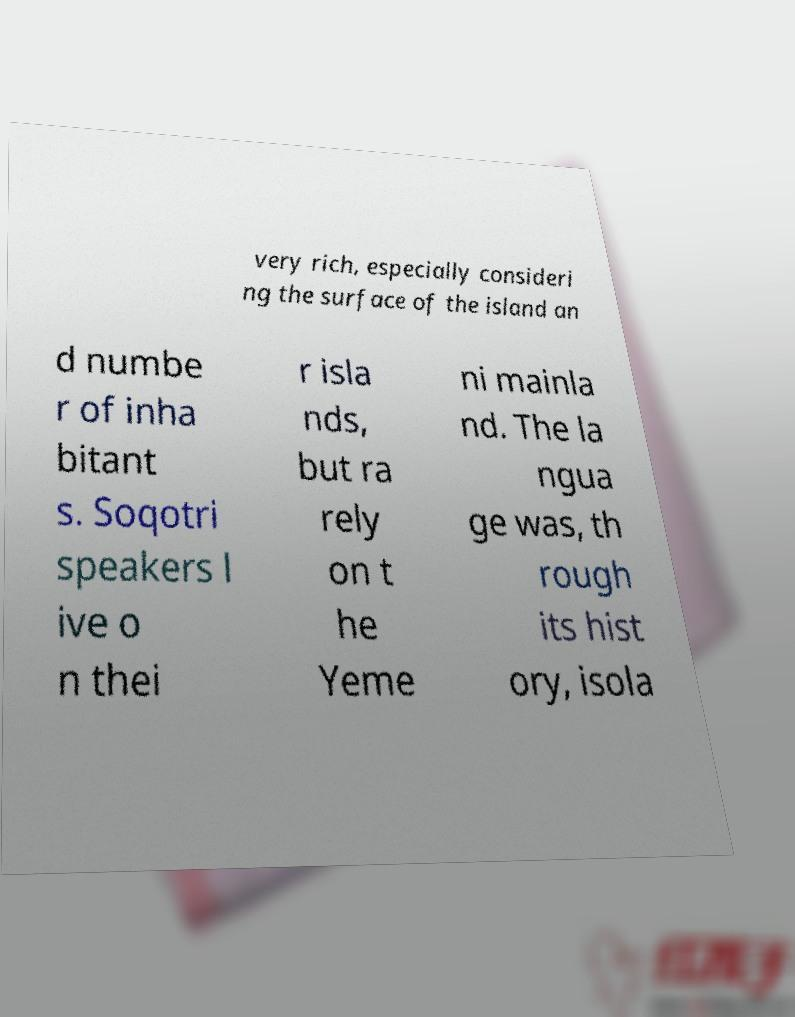For documentation purposes, I need the text within this image transcribed. Could you provide that? very rich, especially consideri ng the surface of the island an d numbe r of inha bitant s. Soqotri speakers l ive o n thei r isla nds, but ra rely on t he Yeme ni mainla nd. The la ngua ge was, th rough its hist ory, isola 